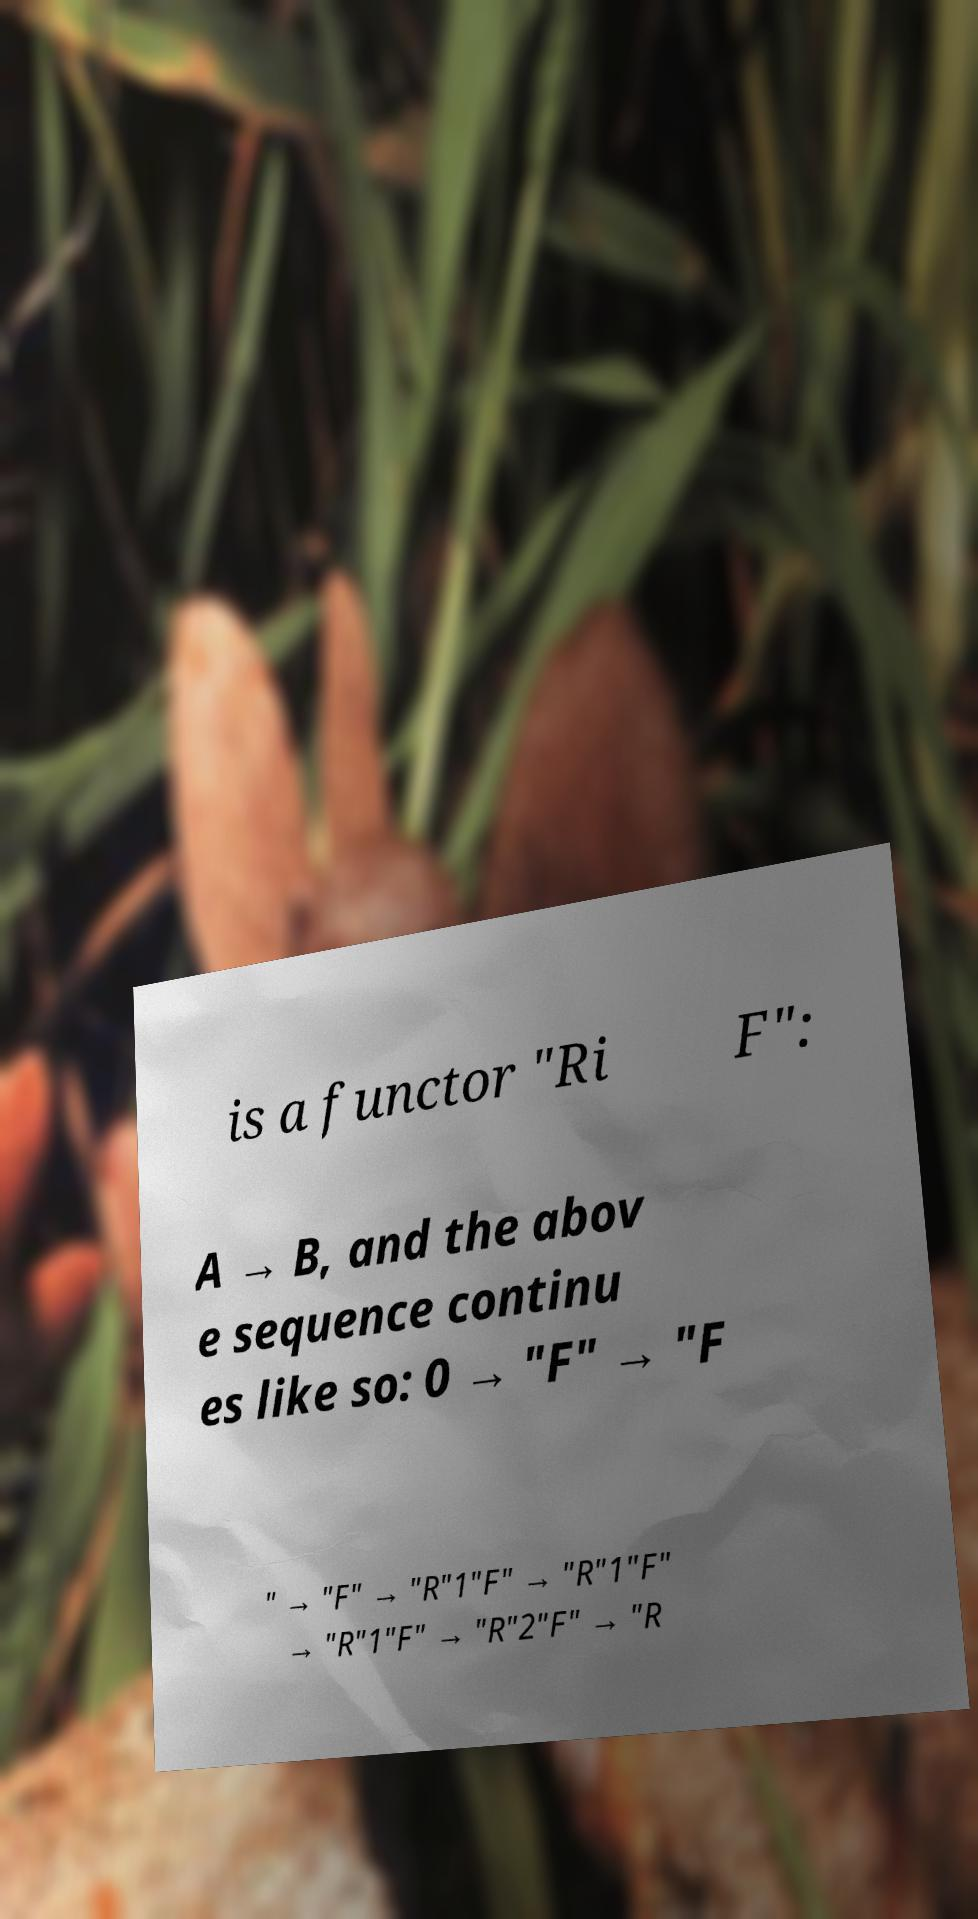Could you assist in decoding the text presented in this image and type it out clearly? is a functor "Ri F": A → B, and the abov e sequence continu es like so: 0 → "F" → "F " → "F" → "R"1"F" → "R"1"F" → "R"1"F" → "R"2"F" → "R 